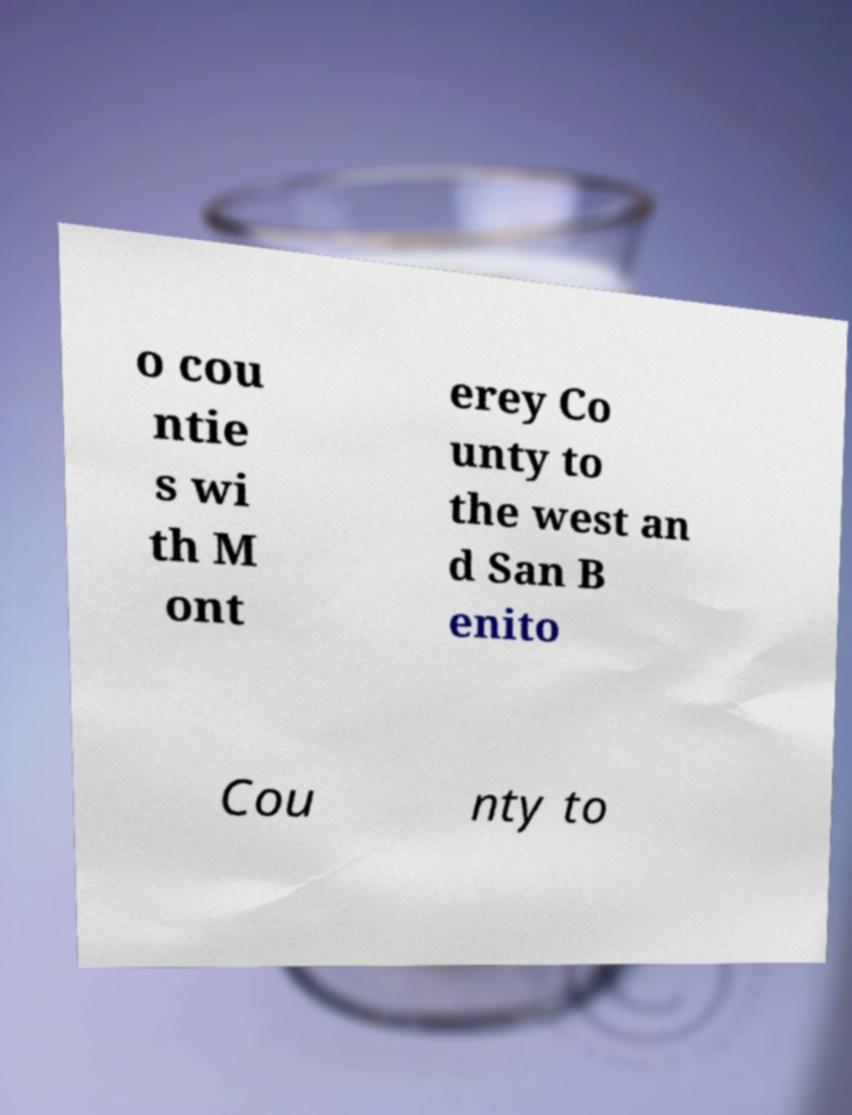Could you assist in decoding the text presented in this image and type it out clearly? o cou ntie s wi th M ont erey Co unty to the west an d San B enito Cou nty to 